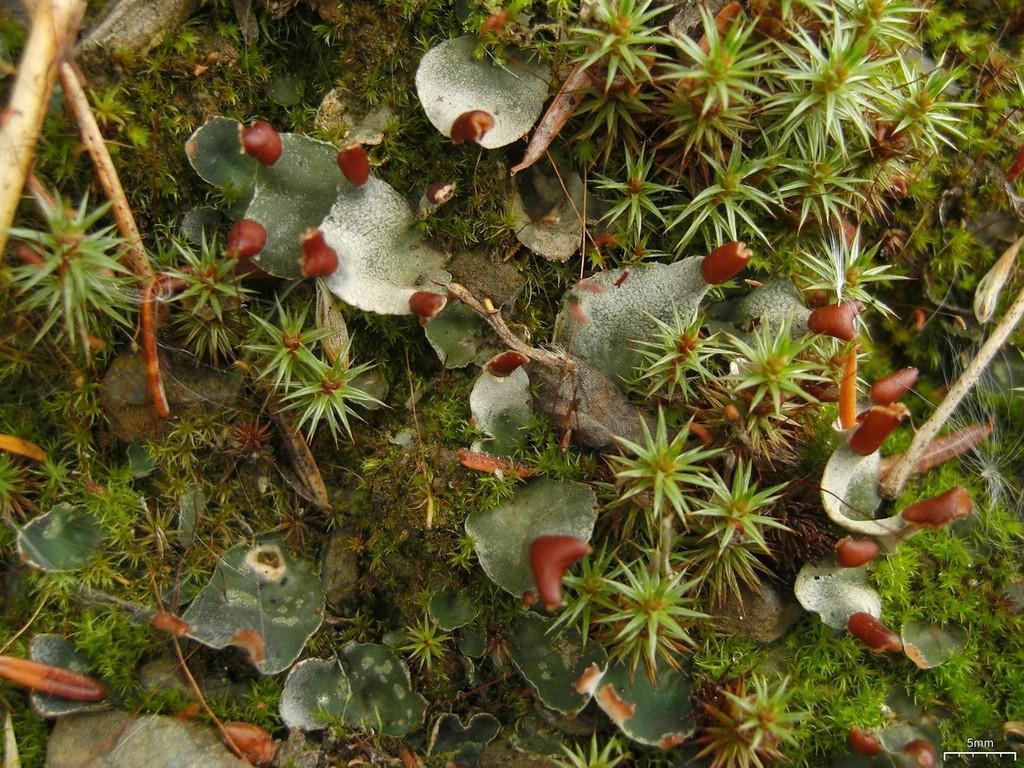How would you summarize this image in a sentence or two? In this image I can see few plants which are green and red in color on the ground. I can see few wooden sticks which are brown in color. 